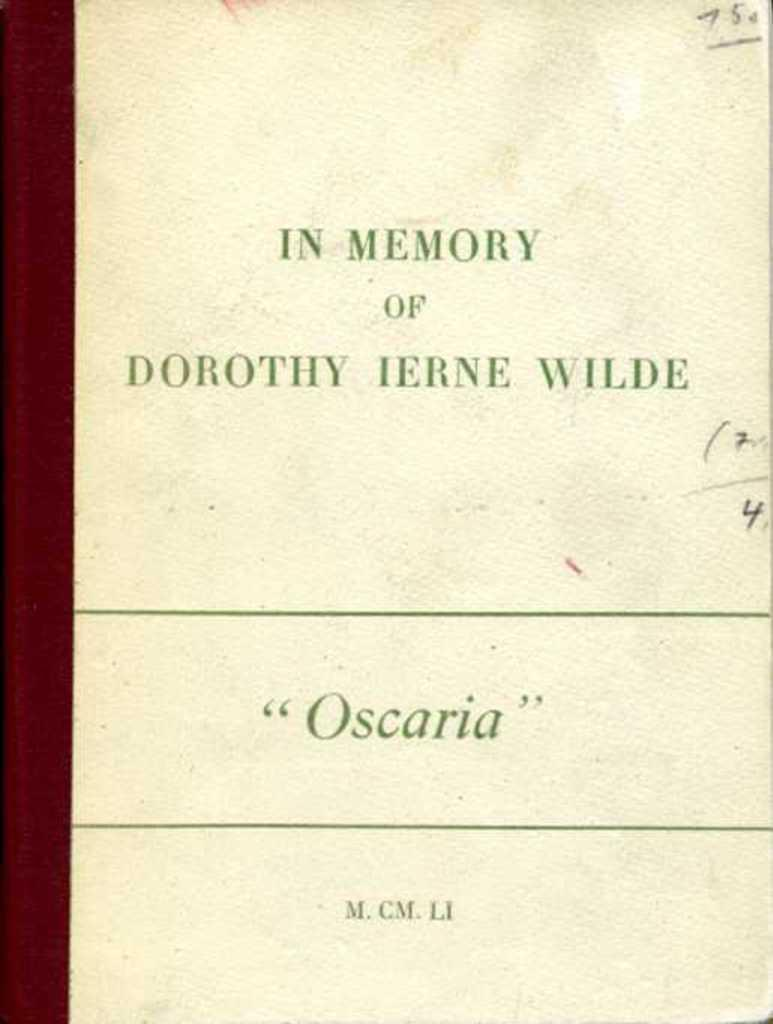<image>
Share a concise interpretation of the image provided. The work "Oscaria" was written in memory of Dorothy Ierne Wilde. 